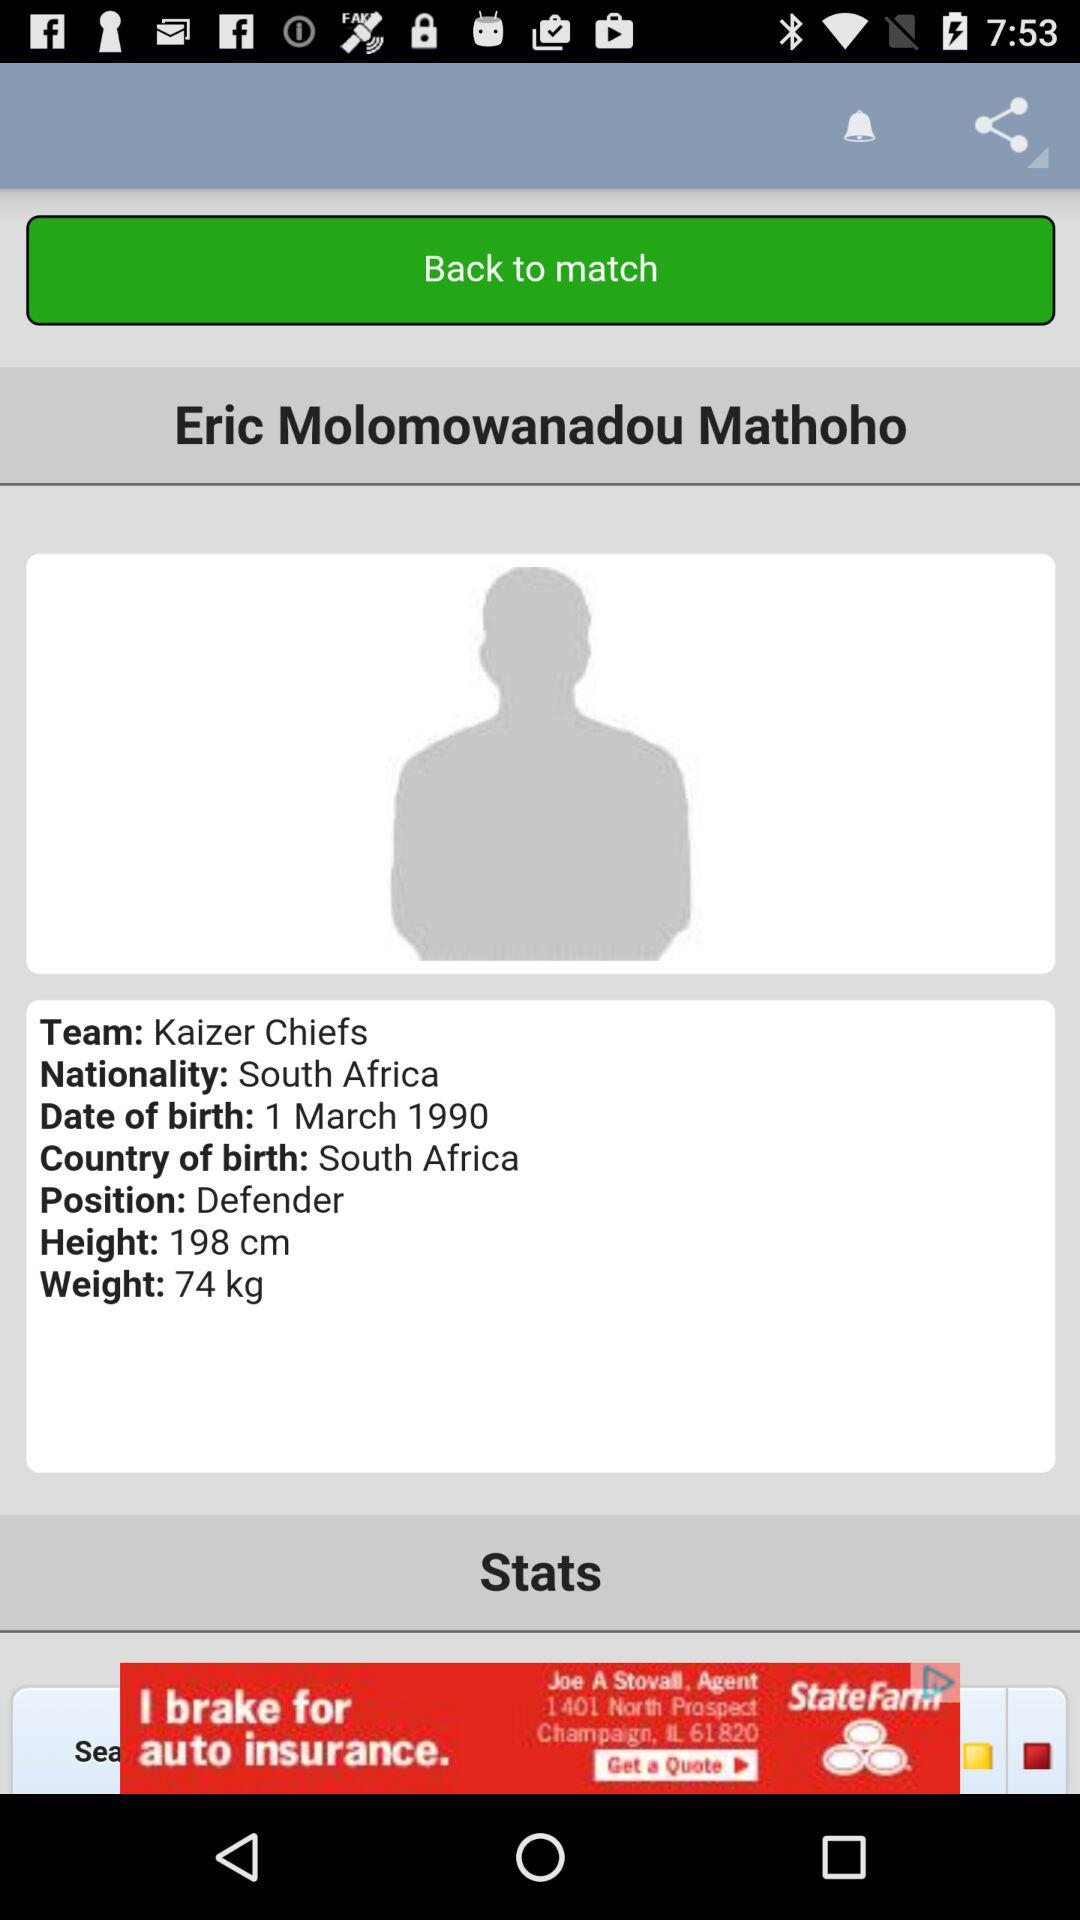What is the height? The height is 198 cm. 